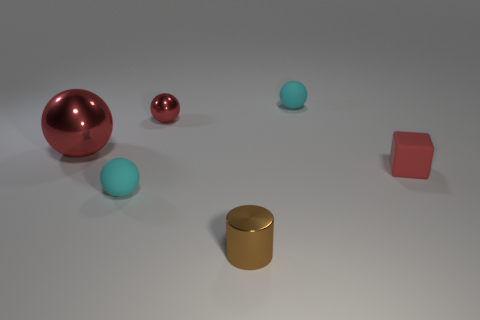Add 3 tiny things. How many objects exist? 9 Subtract all cylinders. How many objects are left? 5 Subtract 0 green cubes. How many objects are left? 6 Subtract all small yellow shiny blocks. Subtract all brown shiny cylinders. How many objects are left? 5 Add 6 big red metallic spheres. How many big red metallic spheres are left? 7 Add 1 small metallic spheres. How many small metallic spheres exist? 2 